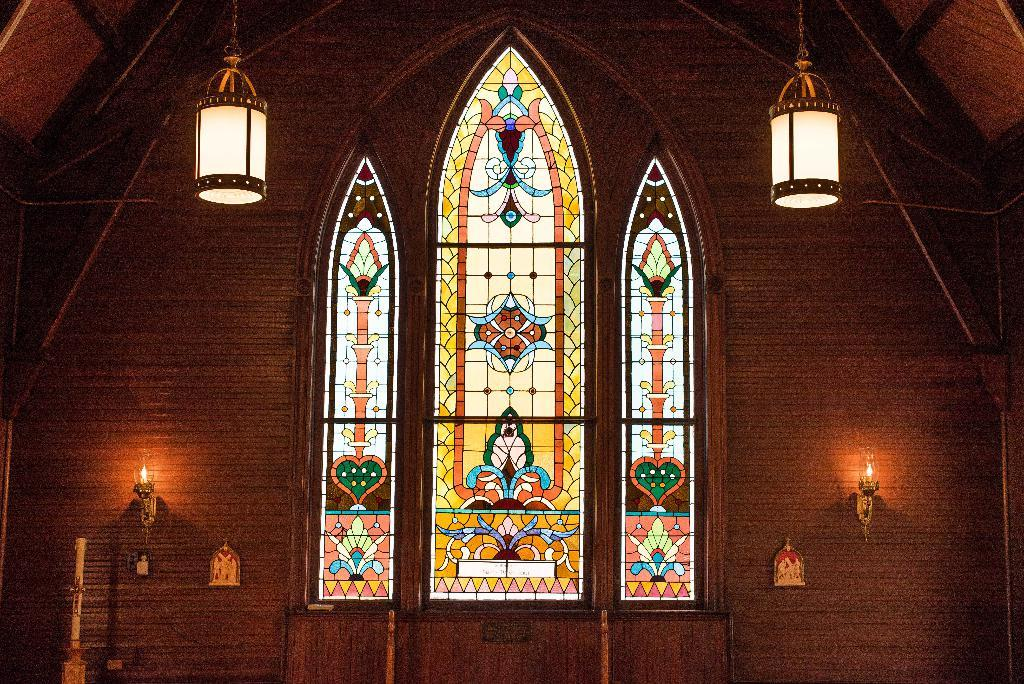What type of location is depicted in the image? The image is an inside picture of a building. What is the main feature in the center of the image? There is a glass art in the center of the image. What material is used for the walls in the image? The walls are made of wood. Can you describe the lighting in the image? There are lights visible in the image. What type of field can be seen through the glass art in the image? There is no field visible through the glass art in the image; it is an inside picture of a building. Can you hear any sounds coming from the glass art in the image? The image is a still picture, so there is no sound or hearing involved. 